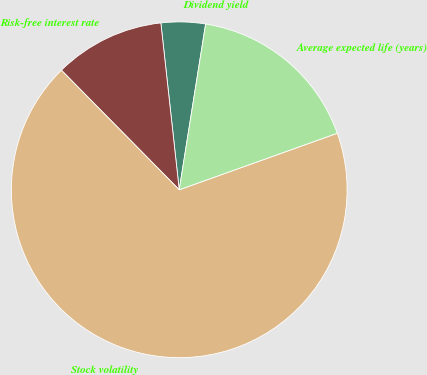<chart> <loc_0><loc_0><loc_500><loc_500><pie_chart><fcel>Dividend yield<fcel>Risk-free interest rate<fcel>Stock volatility<fcel>Average expected life (years)<nl><fcel>4.26%<fcel>10.64%<fcel>68.09%<fcel>17.02%<nl></chart> 